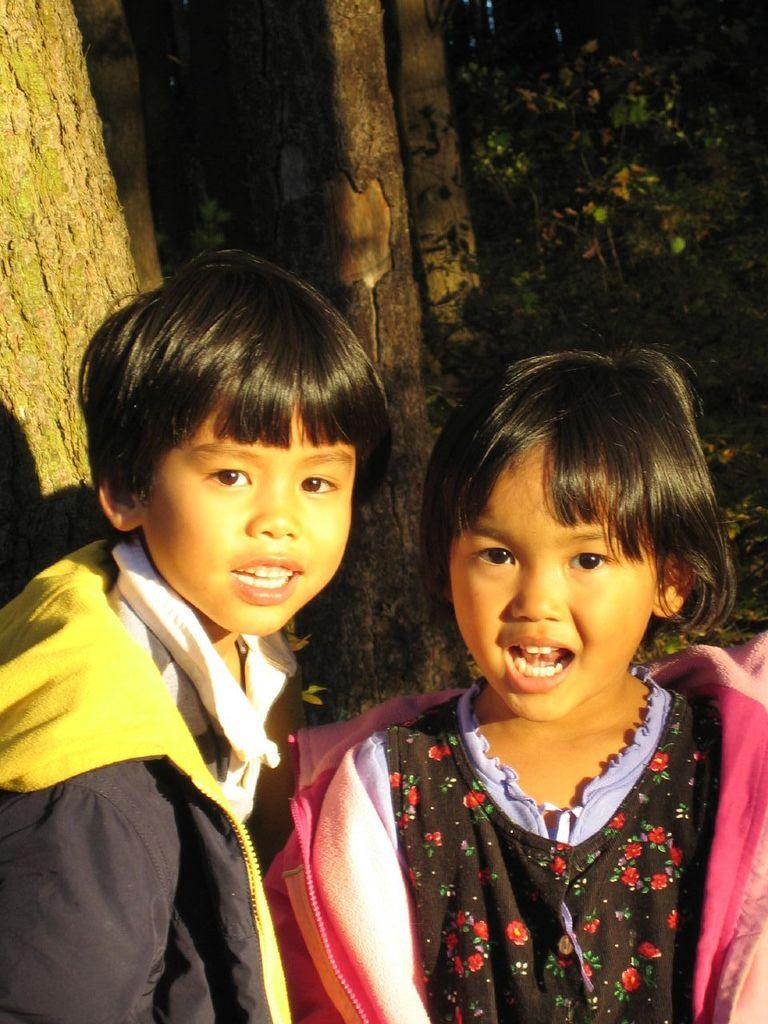What is the main subject in the foreground of the image? There is a girl and a boy in the foreground of the image. What are the children wearing? The girl is wearing a pink coat, and the boy is wearing a black coat. What is the children standing in front of? The children are standing in front of a tree trunk. What can be seen in the background of the image? There are trees in the background of the image. What type of force is being applied to the ink in the image? There is no ink or force present in the image. Is there a rifle visible in the image? No, there is no rifle present in the image. 